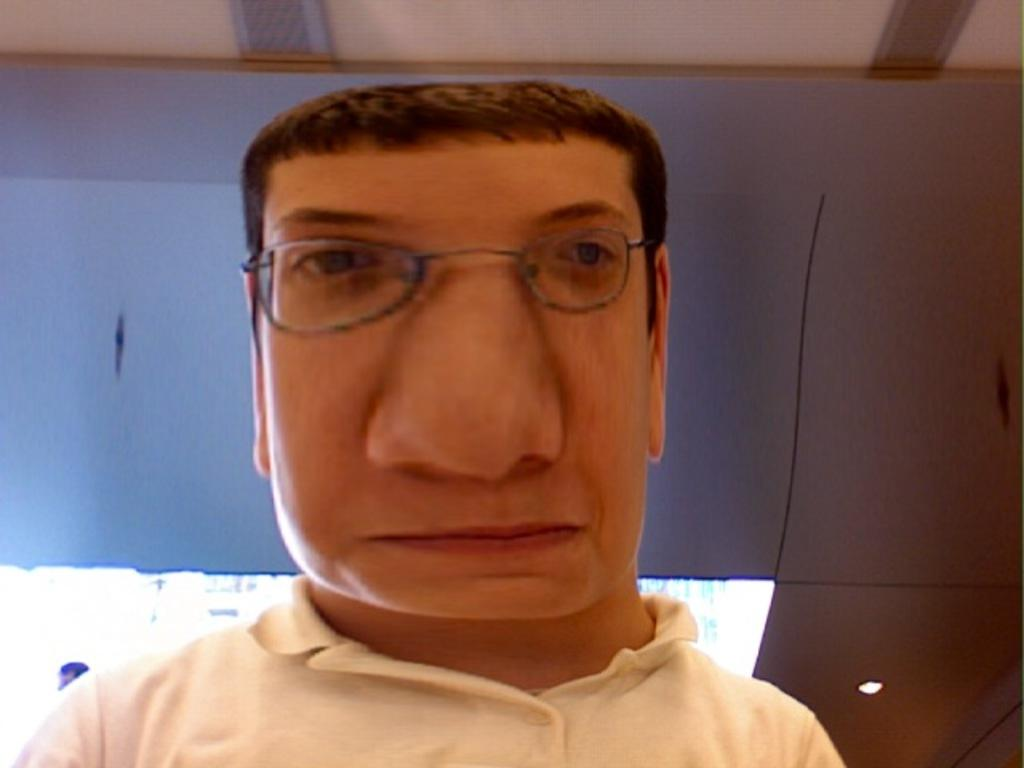What type of picture is shown in the image? The image is an edited picture of a man. What can be seen on the man's face? The man is wearing spectacles. What is the man wearing on his upper body? The man is wearing a white t-shirt. What is visible on the roof in the image? There are lights visible on the roof. What type of tooth is visible in the man's mouth in the image? There is no tooth visible in the man's mouth in the image. What type of collar is the man wearing in the image? The man is not wearing a collar in the image, as he is wearing a t-shirt. 